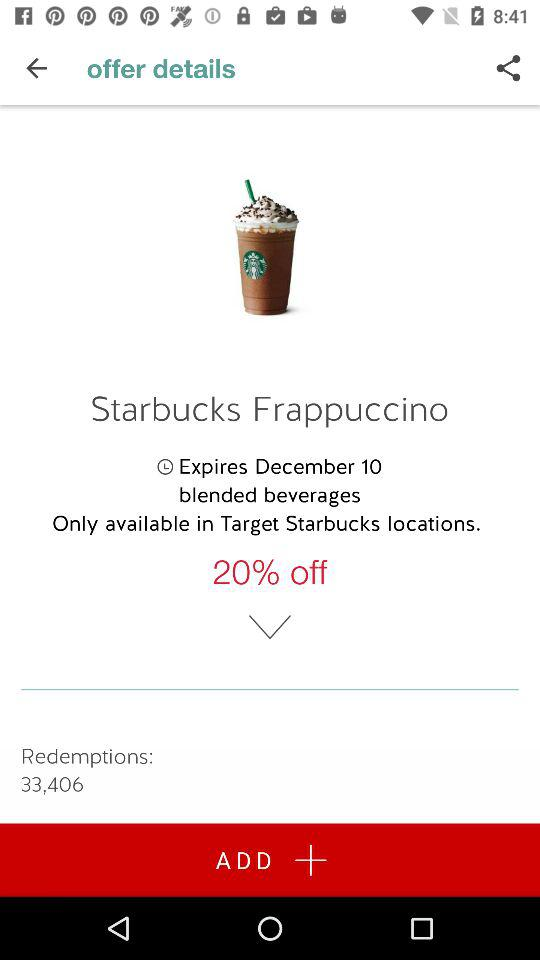How many redemptions have been made for this offer?
Answer the question using a single word or phrase. 33,406 